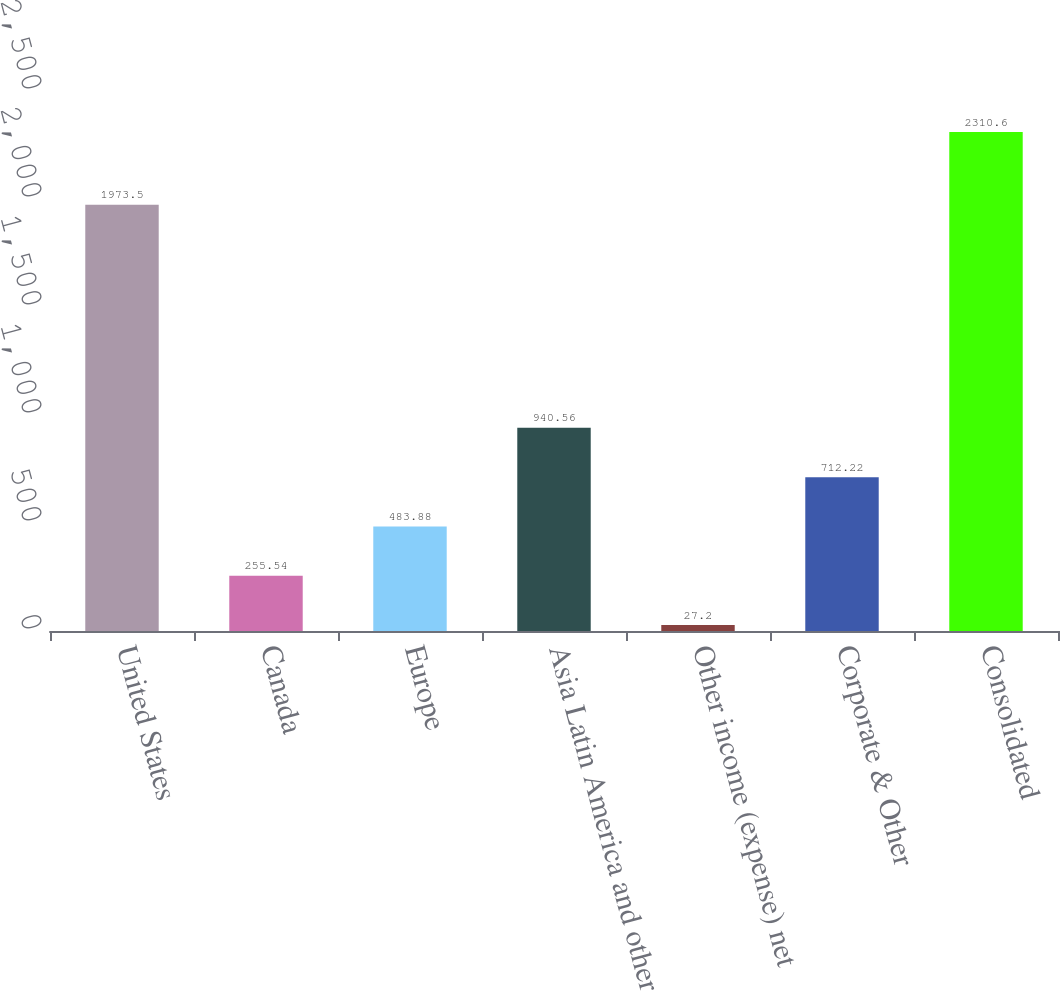<chart> <loc_0><loc_0><loc_500><loc_500><bar_chart><fcel>United States<fcel>Canada<fcel>Europe<fcel>Asia Latin America and other<fcel>Other income (expense) net<fcel>Corporate & Other<fcel>Consolidated<nl><fcel>1973.5<fcel>255.54<fcel>483.88<fcel>940.56<fcel>27.2<fcel>712.22<fcel>2310.6<nl></chart> 